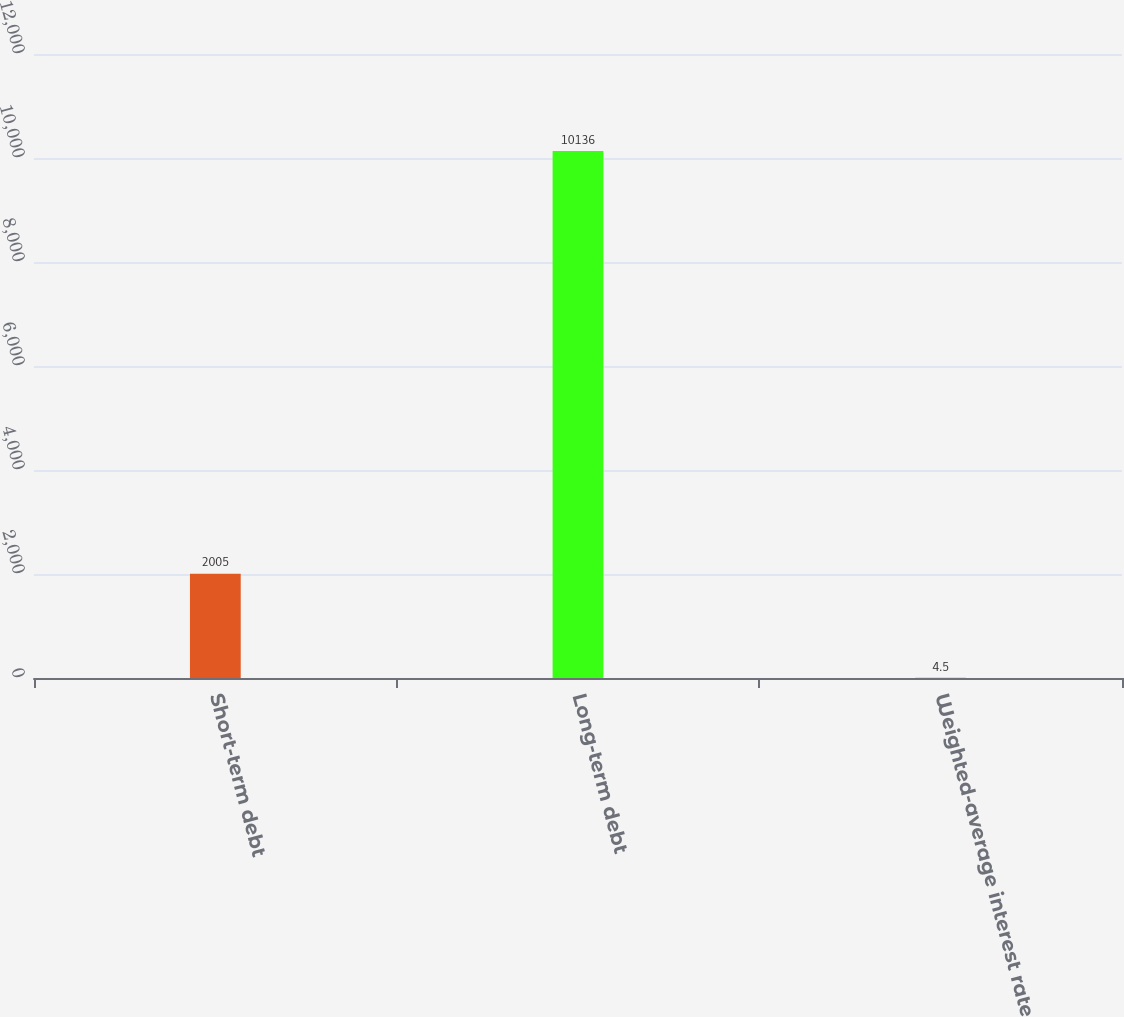Convert chart. <chart><loc_0><loc_0><loc_500><loc_500><bar_chart><fcel>Short-term debt<fcel>Long-term debt<fcel>Weighted-average interest rate<nl><fcel>2005<fcel>10136<fcel>4.5<nl></chart> 